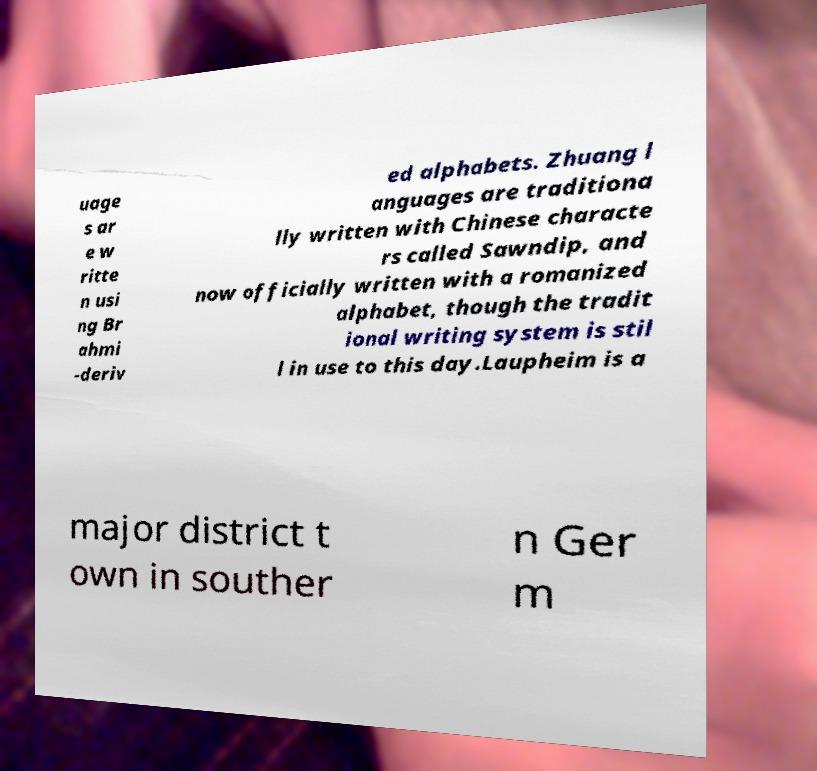Could you extract and type out the text from this image? uage s ar e w ritte n usi ng Br ahmi -deriv ed alphabets. Zhuang l anguages are traditiona lly written with Chinese characte rs called Sawndip, and now officially written with a romanized alphabet, though the tradit ional writing system is stil l in use to this day.Laupheim is a major district t own in souther n Ger m 